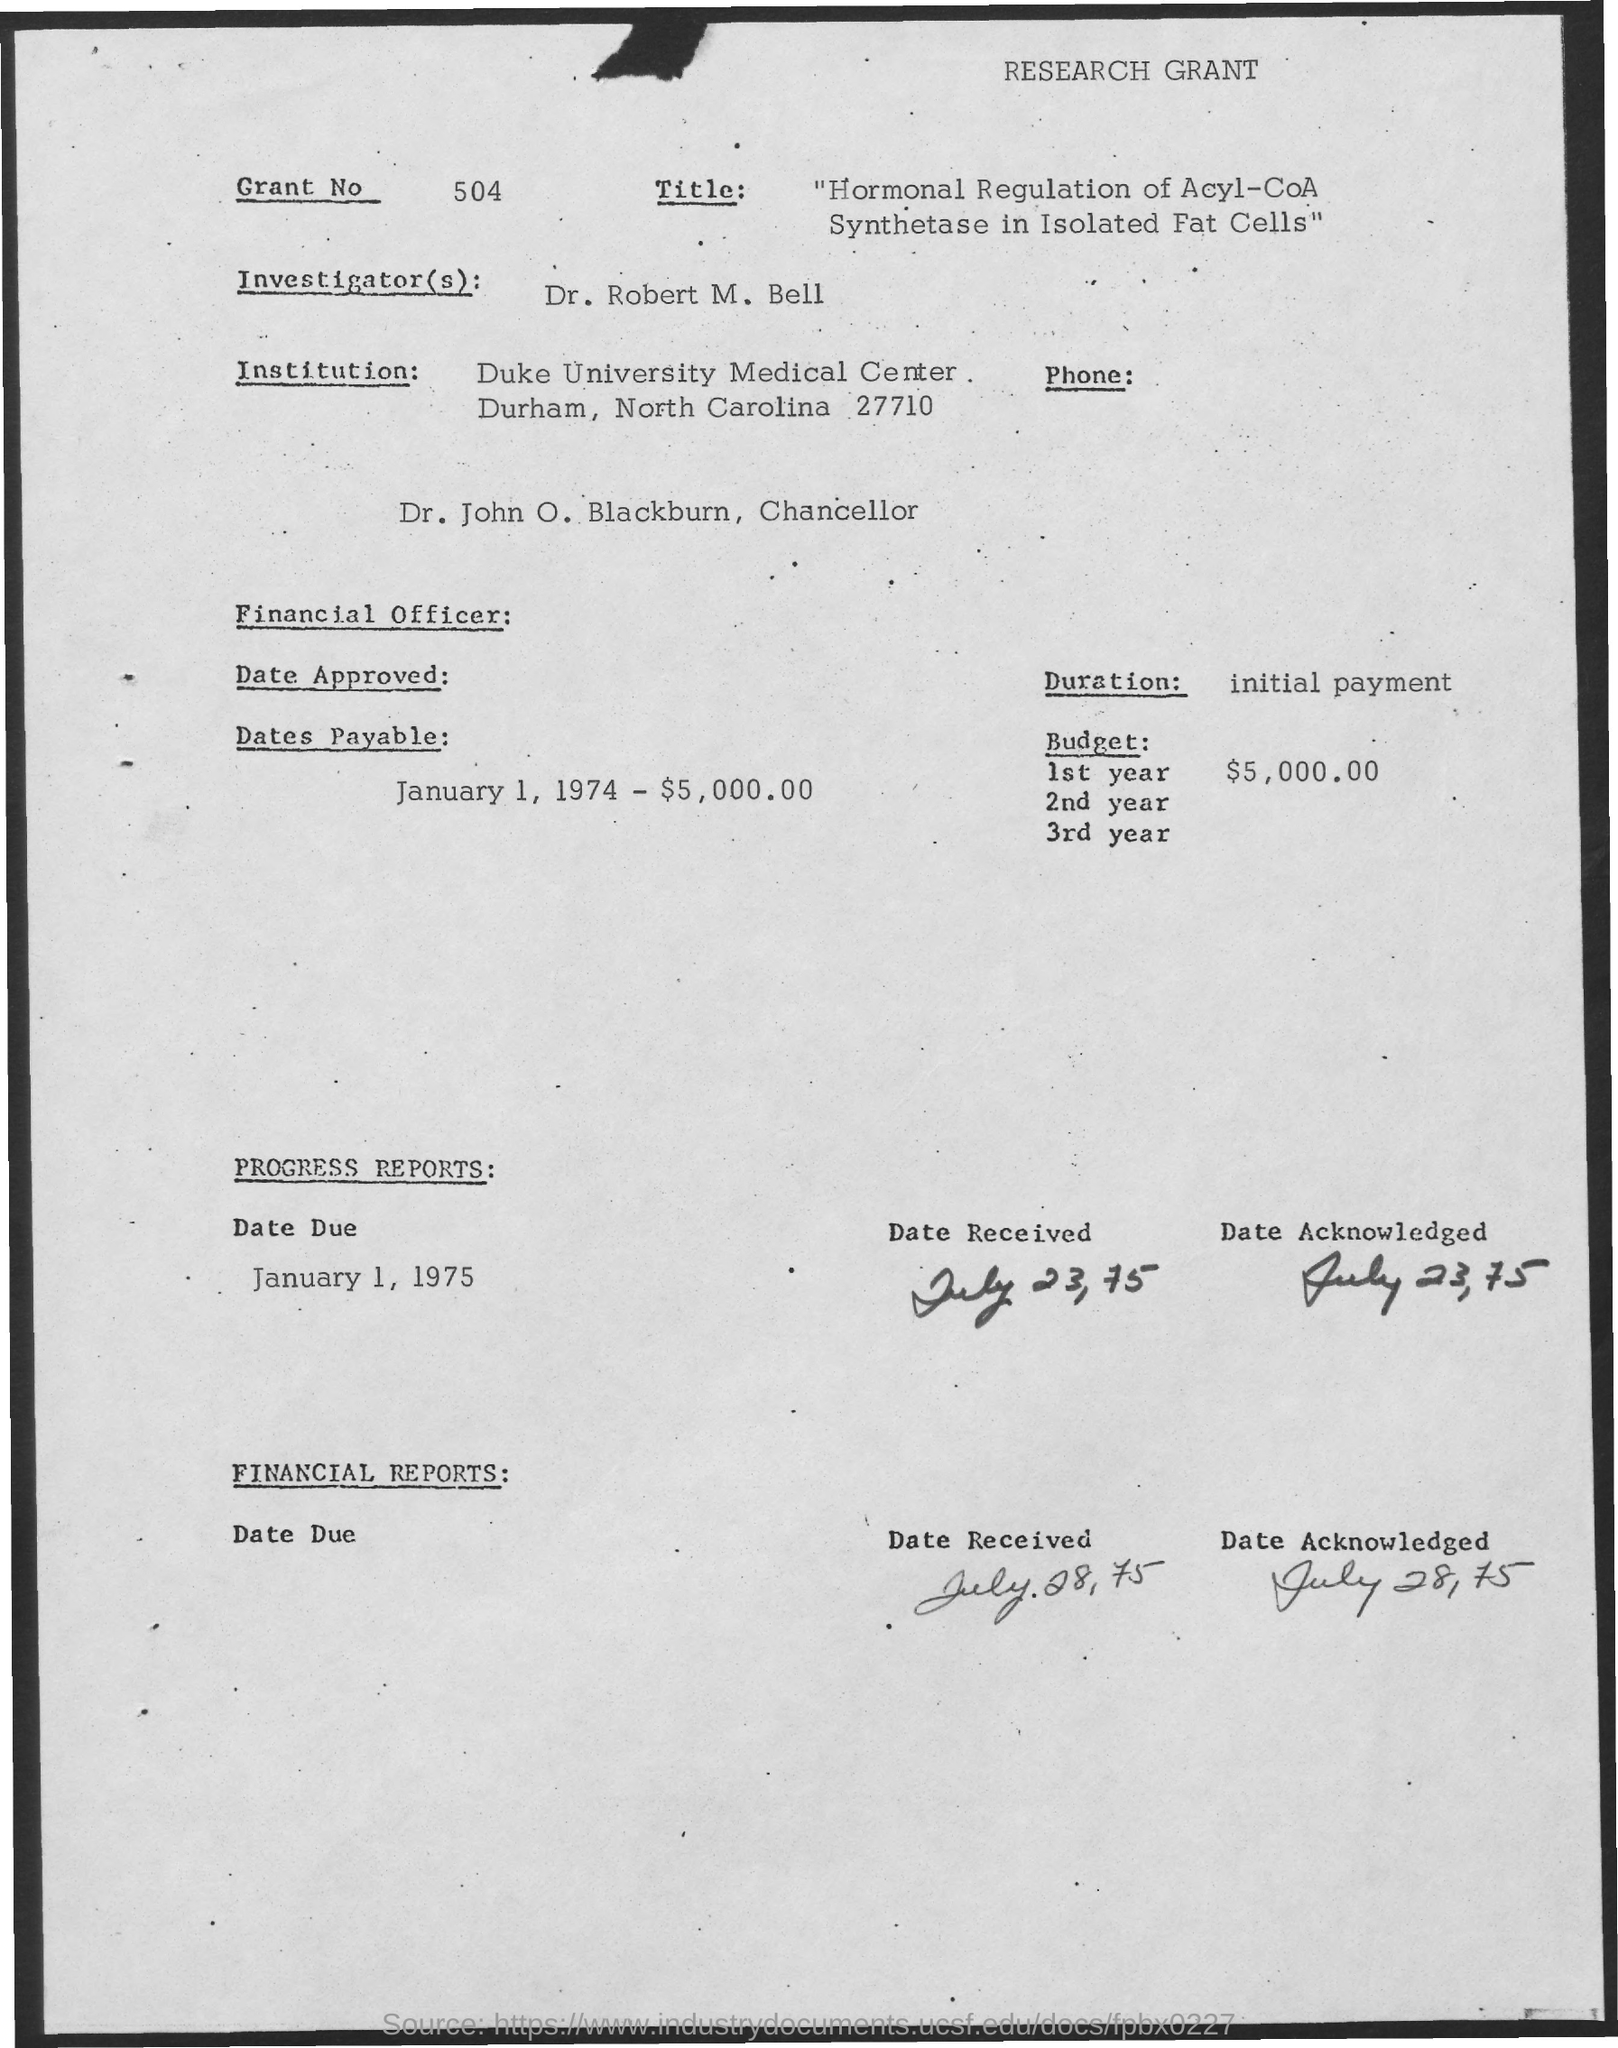List a handful of essential elements in this visual. The investigator mentioned in the document is Dr. Robert M. Bell. The budget estimate for the first year of the research grant is $5,000.00. Who is Dr. John O. Blackburn, the chancellor? The due date for progress reports is January 1, 1975. The received date of the financial reports is July 28, 1975. 